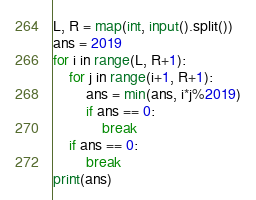<code> <loc_0><loc_0><loc_500><loc_500><_Python_>L, R = map(int, input().split())
ans = 2019
for i in range(L, R+1):
    for j in range(i+1, R+1):
        ans = min(ans, i*j%2019)
        if ans == 0:
            break
    if ans == 0:
        break
print(ans)
</code> 